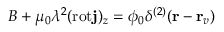Convert formula to latex. <formula><loc_0><loc_0><loc_500><loc_500>B + \mu _ { 0 } \lambda ^ { 2 } ( r o t { j } ) _ { z } = \phi _ { 0 } \delta ^ { ( 2 ) } ( { r } - { r } _ { v } )</formula> 